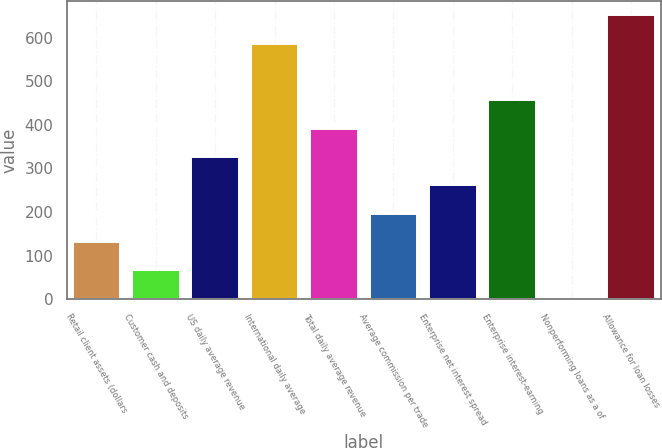Convert chart. <chart><loc_0><loc_0><loc_500><loc_500><bar_chart><fcel>Retail client assets (dollars<fcel>Customer cash and deposits<fcel>US daily average revenue<fcel>International daily average<fcel>Total daily average revenue<fcel>Average commission per trade<fcel>Enterprise net interest spread<fcel>Enterprise interest-earning<fcel>Nonperforming loans as a of<fcel>Allowance for loan losses<nl><fcel>131.07<fcel>66.08<fcel>326.04<fcel>586<fcel>391.03<fcel>196.06<fcel>261.05<fcel>456.02<fcel>1.09<fcel>651<nl></chart> 